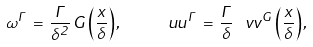<formula> <loc_0><loc_0><loc_500><loc_500>\omega ^ { \Gamma } \, = \, \frac { \Gamma } { \delta ^ { 2 } } \, G \left ( \frac { x } { \delta } \right ) , \quad \ u u ^ { \Gamma } \, = \, \frac { \Gamma } { \delta } \, \ v v ^ { G } \left ( \frac { x } { \delta } \right ) ,</formula> 